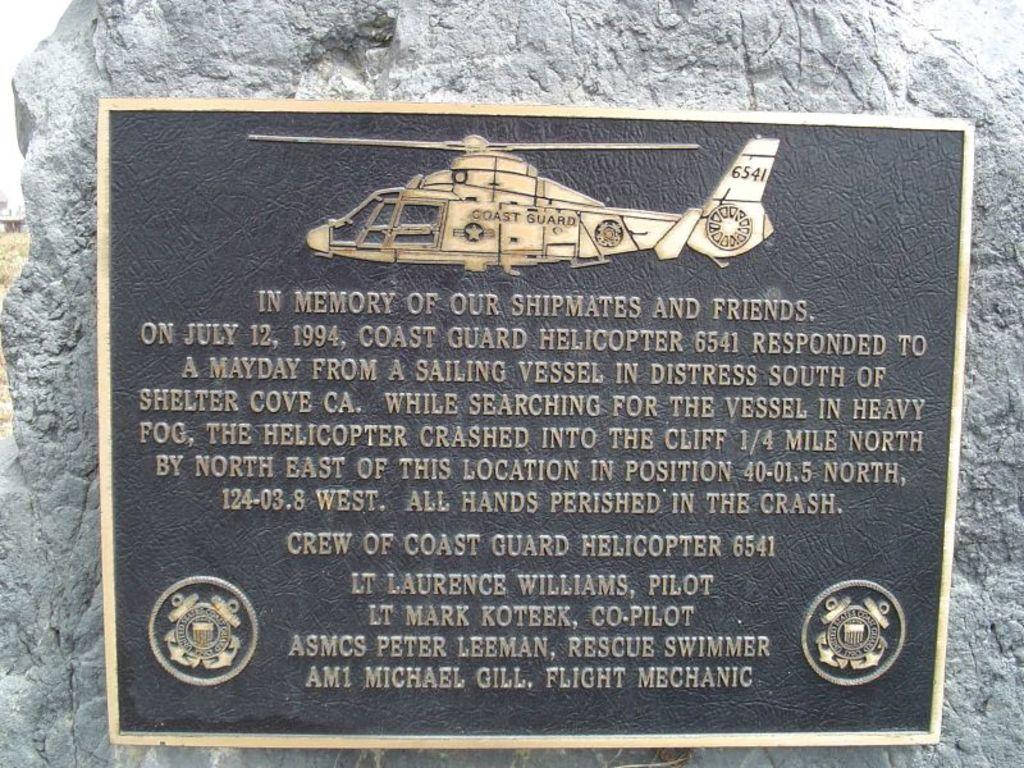<image>
Present a compact description of the photo's key features. A Coast Guard memorial says In Memory of Our Shipmates and Friends. 